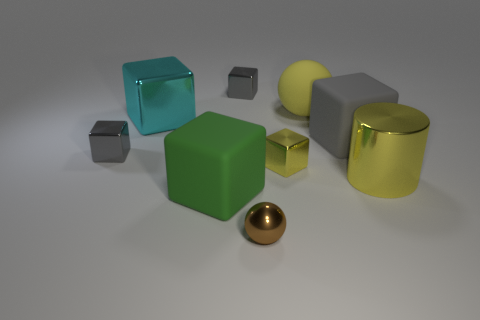How many other objects are the same size as the yellow cylinder?
Ensure brevity in your answer.  4. Are there fewer small cyan objects than large metal objects?
Give a very brief answer. Yes. What is the shape of the cyan metal object?
Your response must be concise. Cube. There is a large rubber block that is to the left of the large gray block; does it have the same color as the big metallic cylinder?
Your answer should be compact. No. There is a thing that is in front of the tiny yellow metallic object and on the right side of the brown object; what shape is it?
Ensure brevity in your answer.  Cylinder. The matte cube to the left of the tiny brown shiny sphere is what color?
Ensure brevity in your answer.  Green. Is there anything else of the same color as the large cylinder?
Offer a very short reply. Yes. Do the cyan cube and the brown ball have the same size?
Ensure brevity in your answer.  No. There is a shiny object that is behind the metallic cylinder and to the right of the brown object; how big is it?
Keep it short and to the point. Small. What number of green objects have the same material as the cyan object?
Give a very brief answer. 0. 